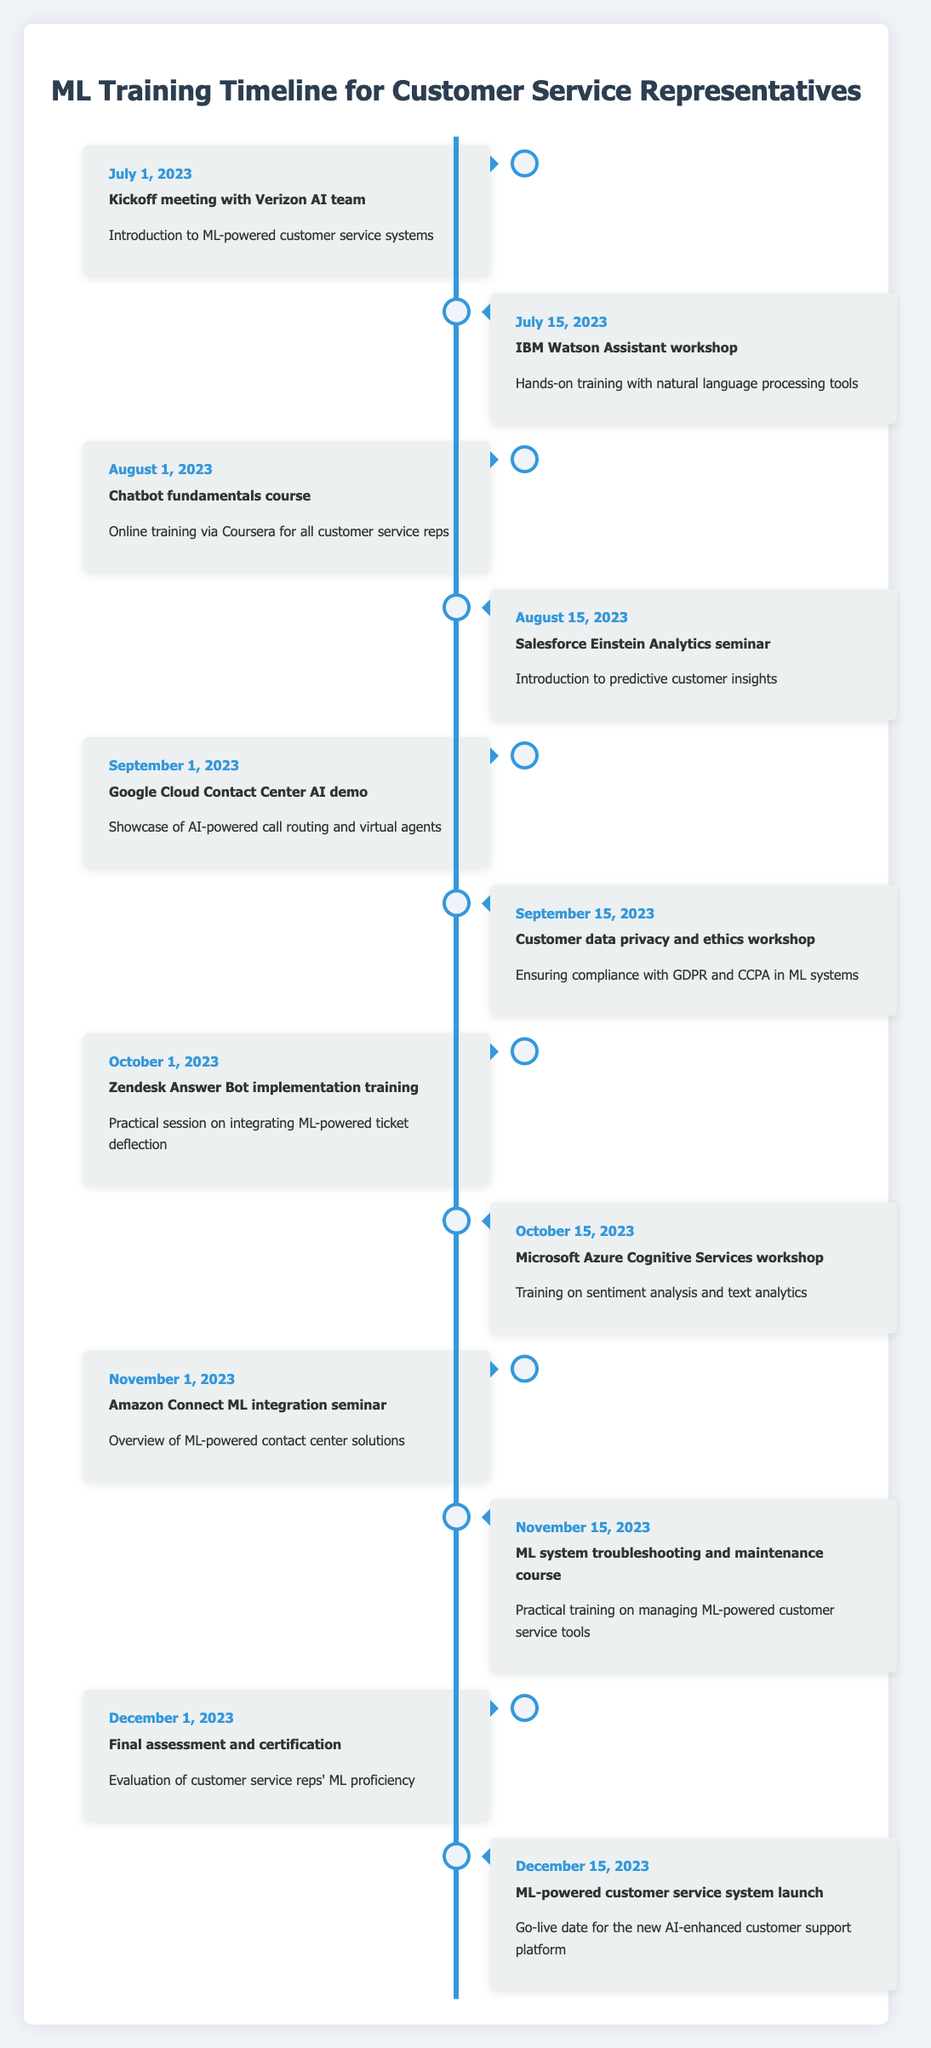What event occurs on July 1, 2023? The event that occurs on July 1, 2023, is the "Kickoff meeting with Verizon AI team." This can be found in the table where the event aligns with that specific date.
Answer: Kickoff meeting with Verizon AI team What is the last event in the timeline? The last event in the timeline is the "ML-powered customer service system launch" on December 15, 2023. This is determined by looking for the last entry in the provided data table.
Answer: ML-powered customer service system launch How many workshops are scheduled in total? Counting all relevant entries labeled as workshops in the table, there are five workshops: IBM Watson Assistant workshop, Customer data privacy and ethics workshop, Zendesk Answer Bot implementation training, Microsoft Azure Cognitive Services workshop, and ML system troubleshooting and maintenance course.
Answer: 5 workshops What is the difference in days between the kickoff meeting and the final assessment? The kickoff meeting is on July 1, 2023, and the final assessment is on December 1, 2023. The total difference is 153 days, which is calculated by determining the days between these two dates: July (30) - 1 + August (31) + September (30) + October (31) + November (30) + December (1) = 153.
Answer: 153 days Is there a training related to data privacy? Yes, there is a workshop called "Customer data privacy and ethics workshop" scheduled for September 15, 2023, which focuses on ensuring compliance with GDPR and CCPA in ML systems.
Answer: Yes What are the two events that take place in October? The two events in October are "Zendesk Answer Bot implementation training" on October 1 and "Microsoft Azure Cognitive Services workshop" on October 15. These details can be extracted by scanning the events for the month of October in the timeline.
Answer: Zendesk Answer Bot implementation training and Microsoft Azure Cognitive Services workshop Which event does the chatbot fundamentals course directly follow? The "Chatbot fundamentals course" occurs right after the "IBM Watson Assistant workshop". The sequence can be confirmed by checking the order of events in the timeline.
Answer: IBM Watson Assistant workshop How many weeks are between the training of Microsoft Azure Cognitive Services and the final assessment? There are about 6 weeks between the "Microsoft Azure Cognitive Services workshop" on October 15, 2023, and the "Final assessment and certification" on December 1, 2023. To compute this, calculate the days between the two dates (47 days) and then convert it to weeks (47 days / 7 days per week = 6.71 weeks, rounding down gives approximately 6 weeks).
Answer: 6 weeks What is the purpose of the "Salesforce Einstein Analytics seminar"? The purpose of the "Salesforce Einstein Analytics seminar" on August 15, 2023, is to introduce predictive customer insights. This information is explicitly mentioned in the description of the event within the table.
Answer: Introduce predictive customer insights 